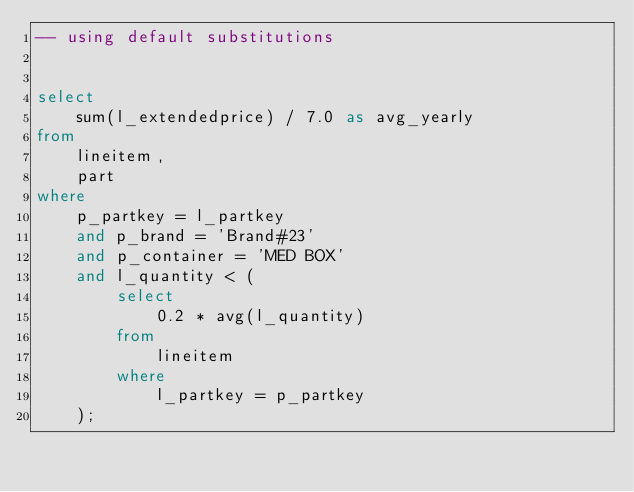<code> <loc_0><loc_0><loc_500><loc_500><_SQL_>-- using default substitutions


select
	sum(l_extendedprice) / 7.0 as avg_yearly
from
	lineitem,
	part
where
	p_partkey = l_partkey
	and p_brand = 'Brand#23'
	and p_container = 'MED BOX'
	and l_quantity < (
		select
			0.2 * avg(l_quantity)
		from
			lineitem
		where
			l_partkey = p_partkey
	);
</code> 